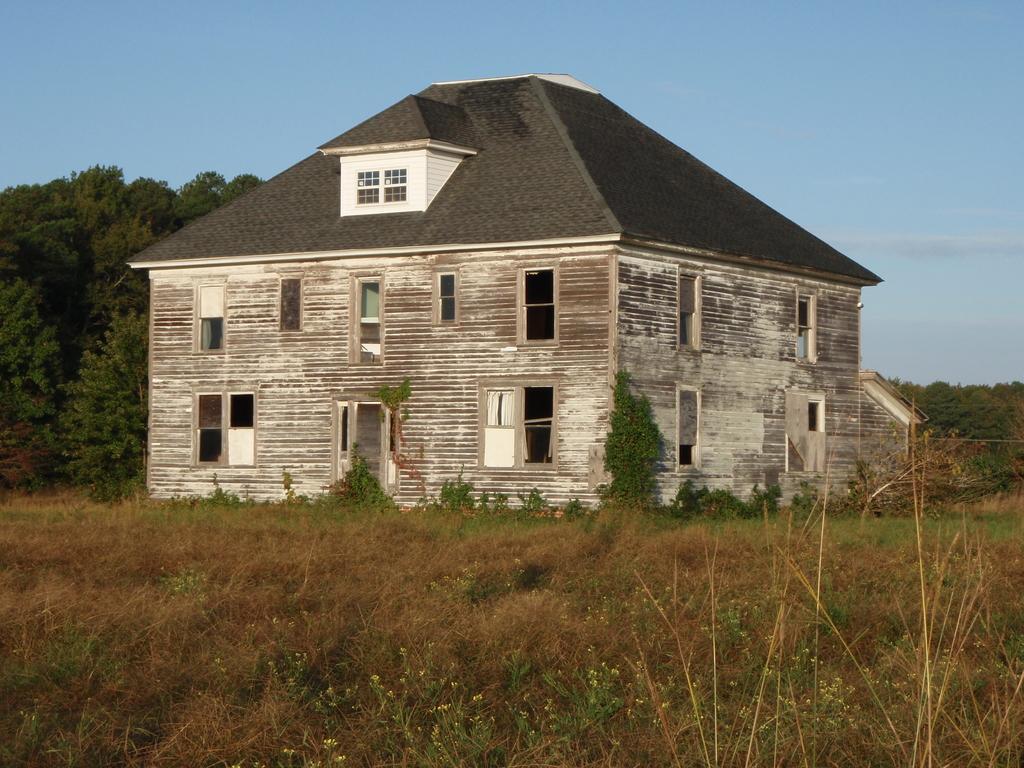Can you describe this image briefly? In this picture there is a house at the center and in front of the house there is a grass on the surface. At the back side there are trees and sky. 